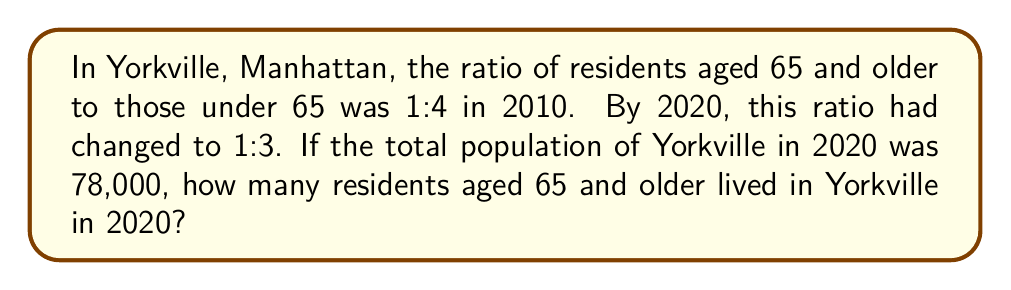Can you solve this math problem? Let's approach this step-by-step:

1) First, we need to understand what the ratio 1:3 means in 2020:
   - For every 1 resident aged 65 and older, there are 3 residents under 65.
   - This means that out of every 4 residents (1 + 3), 1 is 65 or older.

2) We can express this as a fraction:
   $$\frac{\text{Residents 65 and older}}{\text{Total population}} = \frac{1}{4}$$

3) We know the total population in 2020 was 78,000. Let's call the number of residents 65 and older $x$. We can set up the following equation:
   $$\frac{x}{78,000} = \frac{1}{4}$$

4) To solve for $x$, we can cross-multiply:
   $$4x = 78,000$$

5) Now we can divide both sides by 4:
   $$x = \frac{78,000}{4} = 19,500$$

Therefore, in 2020, there were 19,500 residents aged 65 and older in Yorkville, Manhattan.
Answer: 19,500 residents 